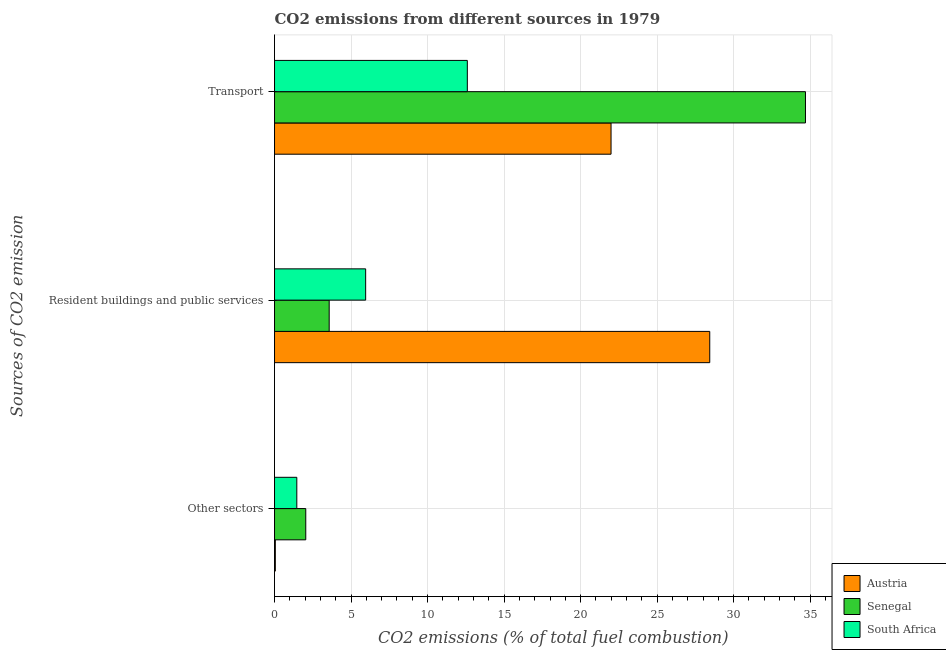How many different coloured bars are there?
Your answer should be compact. 3. Are the number of bars per tick equal to the number of legend labels?
Provide a short and direct response. Yes. Are the number of bars on each tick of the Y-axis equal?
Your response must be concise. Yes. How many bars are there on the 1st tick from the top?
Make the answer very short. 3. What is the label of the 3rd group of bars from the top?
Give a very brief answer. Other sectors. What is the percentage of co2 emissions from transport in Austria?
Offer a very short reply. 21.99. Across all countries, what is the maximum percentage of co2 emissions from resident buildings and public services?
Your answer should be compact. 28.44. Across all countries, what is the minimum percentage of co2 emissions from other sectors?
Keep it short and to the point. 0.05. In which country was the percentage of co2 emissions from other sectors maximum?
Provide a short and direct response. Senegal. In which country was the percentage of co2 emissions from resident buildings and public services minimum?
Your answer should be compact. Senegal. What is the total percentage of co2 emissions from other sectors in the graph?
Provide a short and direct response. 3.55. What is the difference between the percentage of co2 emissions from other sectors in Austria and that in Senegal?
Offer a very short reply. -1.99. What is the difference between the percentage of co2 emissions from transport in Austria and the percentage of co2 emissions from resident buildings and public services in South Africa?
Offer a terse response. 16.04. What is the average percentage of co2 emissions from other sectors per country?
Make the answer very short. 1.18. What is the difference between the percentage of co2 emissions from resident buildings and public services and percentage of co2 emissions from other sectors in Austria?
Your answer should be compact. 28.39. In how many countries, is the percentage of co2 emissions from transport greater than 2 %?
Provide a succinct answer. 3. What is the ratio of the percentage of co2 emissions from transport in Senegal to that in South Africa?
Your response must be concise. 2.75. Is the difference between the percentage of co2 emissions from other sectors in South Africa and Senegal greater than the difference between the percentage of co2 emissions from transport in South Africa and Senegal?
Your answer should be compact. Yes. What is the difference between the highest and the second highest percentage of co2 emissions from resident buildings and public services?
Your answer should be very brief. 22.49. What is the difference between the highest and the lowest percentage of co2 emissions from resident buildings and public services?
Offer a terse response. 24.87. What does the 1st bar from the top in Other sectors represents?
Your answer should be compact. South Africa. Is it the case that in every country, the sum of the percentage of co2 emissions from other sectors and percentage of co2 emissions from resident buildings and public services is greater than the percentage of co2 emissions from transport?
Give a very brief answer. No. Are all the bars in the graph horizontal?
Give a very brief answer. Yes. How many countries are there in the graph?
Provide a short and direct response. 3. What is the difference between two consecutive major ticks on the X-axis?
Your answer should be compact. 5. Are the values on the major ticks of X-axis written in scientific E-notation?
Provide a short and direct response. No. Where does the legend appear in the graph?
Your answer should be compact. Bottom right. How many legend labels are there?
Offer a very short reply. 3. How are the legend labels stacked?
Provide a short and direct response. Vertical. What is the title of the graph?
Ensure brevity in your answer.  CO2 emissions from different sources in 1979. Does "Vietnam" appear as one of the legend labels in the graph?
Keep it short and to the point. No. What is the label or title of the X-axis?
Keep it short and to the point. CO2 emissions (% of total fuel combustion). What is the label or title of the Y-axis?
Your answer should be very brief. Sources of CO2 emission. What is the CO2 emissions (% of total fuel combustion) of Austria in Other sectors?
Provide a short and direct response. 0.05. What is the CO2 emissions (% of total fuel combustion) in Senegal in Other sectors?
Give a very brief answer. 2.04. What is the CO2 emissions (% of total fuel combustion) in South Africa in Other sectors?
Make the answer very short. 1.46. What is the CO2 emissions (% of total fuel combustion) of Austria in Resident buildings and public services?
Give a very brief answer. 28.44. What is the CO2 emissions (% of total fuel combustion) in Senegal in Resident buildings and public services?
Make the answer very short. 3.57. What is the CO2 emissions (% of total fuel combustion) of South Africa in Resident buildings and public services?
Your answer should be compact. 5.95. What is the CO2 emissions (% of total fuel combustion) of Austria in Transport?
Ensure brevity in your answer.  21.99. What is the CO2 emissions (% of total fuel combustion) in Senegal in Transport?
Keep it short and to the point. 34.69. What is the CO2 emissions (% of total fuel combustion) of South Africa in Transport?
Offer a terse response. 12.6. Across all Sources of CO2 emission, what is the maximum CO2 emissions (% of total fuel combustion) in Austria?
Keep it short and to the point. 28.44. Across all Sources of CO2 emission, what is the maximum CO2 emissions (% of total fuel combustion) in Senegal?
Offer a very short reply. 34.69. Across all Sources of CO2 emission, what is the maximum CO2 emissions (% of total fuel combustion) of South Africa?
Your answer should be very brief. 12.6. Across all Sources of CO2 emission, what is the minimum CO2 emissions (% of total fuel combustion) in Austria?
Offer a terse response. 0.05. Across all Sources of CO2 emission, what is the minimum CO2 emissions (% of total fuel combustion) of Senegal?
Give a very brief answer. 2.04. Across all Sources of CO2 emission, what is the minimum CO2 emissions (% of total fuel combustion) of South Africa?
Keep it short and to the point. 1.46. What is the total CO2 emissions (% of total fuel combustion) in Austria in the graph?
Keep it short and to the point. 50.48. What is the total CO2 emissions (% of total fuel combustion) in Senegal in the graph?
Keep it short and to the point. 40.31. What is the total CO2 emissions (% of total fuel combustion) in South Africa in the graph?
Your response must be concise. 20.01. What is the difference between the CO2 emissions (% of total fuel combustion) of Austria in Other sectors and that in Resident buildings and public services?
Keep it short and to the point. -28.39. What is the difference between the CO2 emissions (% of total fuel combustion) of Senegal in Other sectors and that in Resident buildings and public services?
Make the answer very short. -1.53. What is the difference between the CO2 emissions (% of total fuel combustion) of South Africa in Other sectors and that in Resident buildings and public services?
Keep it short and to the point. -4.5. What is the difference between the CO2 emissions (% of total fuel combustion) of Austria in Other sectors and that in Transport?
Offer a very short reply. -21.94. What is the difference between the CO2 emissions (% of total fuel combustion) in Senegal in Other sectors and that in Transport?
Give a very brief answer. -32.65. What is the difference between the CO2 emissions (% of total fuel combustion) in South Africa in Other sectors and that in Transport?
Give a very brief answer. -11.14. What is the difference between the CO2 emissions (% of total fuel combustion) of Austria in Resident buildings and public services and that in Transport?
Your response must be concise. 6.45. What is the difference between the CO2 emissions (% of total fuel combustion) of Senegal in Resident buildings and public services and that in Transport?
Ensure brevity in your answer.  -31.12. What is the difference between the CO2 emissions (% of total fuel combustion) of South Africa in Resident buildings and public services and that in Transport?
Keep it short and to the point. -6.64. What is the difference between the CO2 emissions (% of total fuel combustion) of Austria in Other sectors and the CO2 emissions (% of total fuel combustion) of Senegal in Resident buildings and public services?
Your answer should be very brief. -3.52. What is the difference between the CO2 emissions (% of total fuel combustion) of Austria in Other sectors and the CO2 emissions (% of total fuel combustion) of South Africa in Resident buildings and public services?
Offer a very short reply. -5.9. What is the difference between the CO2 emissions (% of total fuel combustion) in Senegal in Other sectors and the CO2 emissions (% of total fuel combustion) in South Africa in Resident buildings and public services?
Offer a very short reply. -3.91. What is the difference between the CO2 emissions (% of total fuel combustion) of Austria in Other sectors and the CO2 emissions (% of total fuel combustion) of Senegal in Transport?
Ensure brevity in your answer.  -34.64. What is the difference between the CO2 emissions (% of total fuel combustion) in Austria in Other sectors and the CO2 emissions (% of total fuel combustion) in South Africa in Transport?
Keep it short and to the point. -12.55. What is the difference between the CO2 emissions (% of total fuel combustion) in Senegal in Other sectors and the CO2 emissions (% of total fuel combustion) in South Africa in Transport?
Provide a short and direct response. -10.56. What is the difference between the CO2 emissions (% of total fuel combustion) in Austria in Resident buildings and public services and the CO2 emissions (% of total fuel combustion) in Senegal in Transport?
Your response must be concise. -6.25. What is the difference between the CO2 emissions (% of total fuel combustion) of Austria in Resident buildings and public services and the CO2 emissions (% of total fuel combustion) of South Africa in Transport?
Make the answer very short. 15.84. What is the difference between the CO2 emissions (% of total fuel combustion) of Senegal in Resident buildings and public services and the CO2 emissions (% of total fuel combustion) of South Africa in Transport?
Keep it short and to the point. -9.03. What is the average CO2 emissions (% of total fuel combustion) in Austria per Sources of CO2 emission?
Your answer should be compact. 16.83. What is the average CO2 emissions (% of total fuel combustion) of Senegal per Sources of CO2 emission?
Keep it short and to the point. 13.44. What is the average CO2 emissions (% of total fuel combustion) of South Africa per Sources of CO2 emission?
Make the answer very short. 6.67. What is the difference between the CO2 emissions (% of total fuel combustion) of Austria and CO2 emissions (% of total fuel combustion) of Senegal in Other sectors?
Provide a succinct answer. -1.99. What is the difference between the CO2 emissions (% of total fuel combustion) in Austria and CO2 emissions (% of total fuel combustion) in South Africa in Other sectors?
Keep it short and to the point. -1.4. What is the difference between the CO2 emissions (% of total fuel combustion) in Senegal and CO2 emissions (% of total fuel combustion) in South Africa in Other sectors?
Your answer should be compact. 0.58. What is the difference between the CO2 emissions (% of total fuel combustion) in Austria and CO2 emissions (% of total fuel combustion) in Senegal in Resident buildings and public services?
Your answer should be compact. 24.87. What is the difference between the CO2 emissions (% of total fuel combustion) in Austria and CO2 emissions (% of total fuel combustion) in South Africa in Resident buildings and public services?
Your answer should be very brief. 22.48. What is the difference between the CO2 emissions (% of total fuel combustion) in Senegal and CO2 emissions (% of total fuel combustion) in South Africa in Resident buildings and public services?
Ensure brevity in your answer.  -2.38. What is the difference between the CO2 emissions (% of total fuel combustion) in Austria and CO2 emissions (% of total fuel combustion) in Senegal in Transport?
Offer a very short reply. -12.7. What is the difference between the CO2 emissions (% of total fuel combustion) of Austria and CO2 emissions (% of total fuel combustion) of South Africa in Transport?
Your answer should be compact. 9.39. What is the difference between the CO2 emissions (% of total fuel combustion) of Senegal and CO2 emissions (% of total fuel combustion) of South Africa in Transport?
Your response must be concise. 22.1. What is the ratio of the CO2 emissions (% of total fuel combustion) in Austria in Other sectors to that in Resident buildings and public services?
Make the answer very short. 0. What is the ratio of the CO2 emissions (% of total fuel combustion) of South Africa in Other sectors to that in Resident buildings and public services?
Offer a terse response. 0.24. What is the ratio of the CO2 emissions (% of total fuel combustion) in Austria in Other sectors to that in Transport?
Ensure brevity in your answer.  0. What is the ratio of the CO2 emissions (% of total fuel combustion) of Senegal in Other sectors to that in Transport?
Make the answer very short. 0.06. What is the ratio of the CO2 emissions (% of total fuel combustion) of South Africa in Other sectors to that in Transport?
Ensure brevity in your answer.  0.12. What is the ratio of the CO2 emissions (% of total fuel combustion) in Austria in Resident buildings and public services to that in Transport?
Provide a short and direct response. 1.29. What is the ratio of the CO2 emissions (% of total fuel combustion) of Senegal in Resident buildings and public services to that in Transport?
Provide a succinct answer. 0.1. What is the ratio of the CO2 emissions (% of total fuel combustion) in South Africa in Resident buildings and public services to that in Transport?
Offer a terse response. 0.47. What is the difference between the highest and the second highest CO2 emissions (% of total fuel combustion) of Austria?
Provide a succinct answer. 6.45. What is the difference between the highest and the second highest CO2 emissions (% of total fuel combustion) of Senegal?
Make the answer very short. 31.12. What is the difference between the highest and the second highest CO2 emissions (% of total fuel combustion) in South Africa?
Your response must be concise. 6.64. What is the difference between the highest and the lowest CO2 emissions (% of total fuel combustion) in Austria?
Offer a terse response. 28.39. What is the difference between the highest and the lowest CO2 emissions (% of total fuel combustion) in Senegal?
Your response must be concise. 32.65. What is the difference between the highest and the lowest CO2 emissions (% of total fuel combustion) in South Africa?
Ensure brevity in your answer.  11.14. 